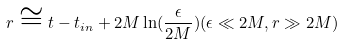Convert formula to latex. <formula><loc_0><loc_0><loc_500><loc_500>r \cong t - t _ { i n } + 2 M \ln ( \frac { \epsilon } { 2 M } ) ( \epsilon \ll 2 M , r \gg 2 M )</formula> 